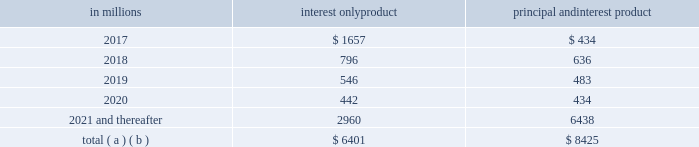Brokered home equity lines of credit ) .
As part of our overall risk analysis and monitoring , we segment the home equity portfolio based upon the loan delinquency , modification status and bankruptcy status , as well as the delinquency , modification status and bankruptcy status of any mortgage loan with the same borrower ( regardless of whether it is a first lien senior to our second lien ) .
In establishing our alll for non-impaired loans , we utilize a delinquency roll-rate methodology for pools of loans .
The roll-rate methodology estimates transition/roll of loan balances from one delinquency state to the next delinquency state and ultimately to charge-off .
The roll through to charge-off is based on our actual loss experience for each type of pool .
Each of our home equity pools contains both first and second liens .
Our experience has been that the ratio of first to second lien loans has been consistent over time and the charge-off amounts for the pools , used to establish our allowance , include losses on both first and second lien loans .
Generally , our variable-rate home equity lines of credit have either a seven or ten year draw period , followed by a 20-year amortization term .
During the draw period , we have home equity lines of credit where borrowers pay either interest only or principal and interest .
We view home equity lines of credit where borrowers are paying principal and interest under the draw period as less risky than those where the borrowers are paying interest only , as these borrowers have a demonstrated ability to make some level of principal and interest payments .
The risk associated with the borrower 2019s ability to satisfy the loan terms upon the draw period ending is considered in establishing our alll .
Based upon outstanding balances at december 31 , 2016 , the table presents the periods when home equity lines of credit draw periods are scheduled to end .
Table 18 : home equity lines of credit 2013 draw period end in millions interest only product principal and interest product .
( a ) includes all home equity lines of credit that mature in 2017 or later , including those with borrowers where we have terminated borrowing privileges .
( b ) includes home equity lines of credit with balloon payments , including those where we have terminated borrowing privileges , of $ 35 million , $ 27 million , $ 20 million , $ 71 million and $ 416 million with draw periods scheduled to end in 2017 , 2018 , 2019 , 2020 and 2021 and thereafter , respectively .
Based upon outstanding balances , and excluding purchased impaired loans , at december 31 , 2016 , for home equity lines of credit for which the borrower can no longer draw ( e.g. , draw period has ended or borrowing privileges have been terminated ) , approximately 3% ( 3 % ) were 30-89 days past due and approximately 6% ( 6 % ) were 90 days or more past due , which are accounted for as nonperforming .
Generally , when a borrower becomes 60 days past due , we terminate borrowing privileges and those privileges are not subsequently reinstated .
At that point , we continue our collection/recovery processes , which may include loan modification resulting in a loan that is classified as a tdr .
Auto loan portfolio the auto loan portfolio totaled $ 12.4 billion as of december 31 , 2016 , or 6% ( 6 % ) of our total loan portfolio .
Of that total , $ 10.8 billion resides in the indirect auto portfolio , $ 1.3 billion in the direct auto portfolio , and $ .3 billion in acquired or securitized portfolios , which has been declining as no pools have been recently acquired .
Indirect auto loan applications are generated from franchised automobile dealers .
This business is strategically aligned with our core retail business .
We have elected not to pursue non-prime auto lending as evidenced by an average new loan origination fico score during 2016 of 760 for indirect auto loans and 775 for direct auto loans .
As of december 31 , 2016 , .4% ( .4 % ) of our auto loan portfolio was nonperforming and .5% ( .5 % ) of the portfolio was accruing past due .
We offer both new and used automobile financing to customers through our various channels .
The portfolio was composed of 57% ( 57 % ) new vehicle loans and 43% ( 43 % ) used vehicle loans at december 31 , 2016 .
The auto loan portfolio 2019s performance is measured monthly , including updated collateral values that are obtained monthly and updated fico scores that are obtained at least quarterly .
For internal reporting and risk management , we analyze the portfolio by product channel and product type , and regularly evaluate default and delinquency experience .
As part of our overall risk analysis and monitoring , we segment the portfolio by loan structure , collateral attributes , and credit metrics which include fico score , loan-to-value and term .
Energy related loan portfolio our portfolio of loans outstanding in the oil and gas industry totaled $ 2.4 billion as of december 31 , 2016 , or 1% ( 1 % ) of our total loan portfolio and 2% ( 2 % ) of our total commercial lending portfolio .
This portfolio comprised approximately $ 1.0 billion in the midstream and downstream sectors , $ .8 billion to oil services companies and $ .6 billion to upstream sectors .
Of the oil services portfolio , approximately $ .2 billion is not asset- based or investment grade .
Nonperforming loans in the oil and gas sector as of december 31 , 2016 totaled $ 184 million , or 8% ( 8 % ) of total nonperforming assets .
Our portfolio of loans outstanding in the coal industry totaled $ .4 billion as of december 31 , 2016 , or less than 1% ( 1 % ) of both our total loan portfolio and our total commercial lending portfolio .
Nonperforming loans in the coal industry as of december 31 , 2016 totaled $ 61 million , or 3% ( 3 % ) of total nonperforming assets .
The pnc financial services group , inc .
2013 form 10-k 57 .
Was the interest only product balance for the 2017 draw period greater than the 2018 draw period?\\n\\n? 
Computations: (1657 > 796)
Answer: yes. Brokered home equity lines of credit ) .
As part of our overall risk analysis and monitoring , we segment the home equity portfolio based upon the loan delinquency , modification status and bankruptcy status , as well as the delinquency , modification status and bankruptcy status of any mortgage loan with the same borrower ( regardless of whether it is a first lien senior to our second lien ) .
In establishing our alll for non-impaired loans , we utilize a delinquency roll-rate methodology for pools of loans .
The roll-rate methodology estimates transition/roll of loan balances from one delinquency state to the next delinquency state and ultimately to charge-off .
The roll through to charge-off is based on our actual loss experience for each type of pool .
Each of our home equity pools contains both first and second liens .
Our experience has been that the ratio of first to second lien loans has been consistent over time and the charge-off amounts for the pools , used to establish our allowance , include losses on both first and second lien loans .
Generally , our variable-rate home equity lines of credit have either a seven or ten year draw period , followed by a 20-year amortization term .
During the draw period , we have home equity lines of credit where borrowers pay either interest only or principal and interest .
We view home equity lines of credit where borrowers are paying principal and interest under the draw period as less risky than those where the borrowers are paying interest only , as these borrowers have a demonstrated ability to make some level of principal and interest payments .
The risk associated with the borrower 2019s ability to satisfy the loan terms upon the draw period ending is considered in establishing our alll .
Based upon outstanding balances at december 31 , 2016 , the table presents the periods when home equity lines of credit draw periods are scheduled to end .
Table 18 : home equity lines of credit 2013 draw period end in millions interest only product principal and interest product .
( a ) includes all home equity lines of credit that mature in 2017 or later , including those with borrowers where we have terminated borrowing privileges .
( b ) includes home equity lines of credit with balloon payments , including those where we have terminated borrowing privileges , of $ 35 million , $ 27 million , $ 20 million , $ 71 million and $ 416 million with draw periods scheduled to end in 2017 , 2018 , 2019 , 2020 and 2021 and thereafter , respectively .
Based upon outstanding balances , and excluding purchased impaired loans , at december 31 , 2016 , for home equity lines of credit for which the borrower can no longer draw ( e.g. , draw period has ended or borrowing privileges have been terminated ) , approximately 3% ( 3 % ) were 30-89 days past due and approximately 6% ( 6 % ) were 90 days or more past due , which are accounted for as nonperforming .
Generally , when a borrower becomes 60 days past due , we terminate borrowing privileges and those privileges are not subsequently reinstated .
At that point , we continue our collection/recovery processes , which may include loan modification resulting in a loan that is classified as a tdr .
Auto loan portfolio the auto loan portfolio totaled $ 12.4 billion as of december 31 , 2016 , or 6% ( 6 % ) of our total loan portfolio .
Of that total , $ 10.8 billion resides in the indirect auto portfolio , $ 1.3 billion in the direct auto portfolio , and $ .3 billion in acquired or securitized portfolios , which has been declining as no pools have been recently acquired .
Indirect auto loan applications are generated from franchised automobile dealers .
This business is strategically aligned with our core retail business .
We have elected not to pursue non-prime auto lending as evidenced by an average new loan origination fico score during 2016 of 760 for indirect auto loans and 775 for direct auto loans .
As of december 31 , 2016 , .4% ( .4 % ) of our auto loan portfolio was nonperforming and .5% ( .5 % ) of the portfolio was accruing past due .
We offer both new and used automobile financing to customers through our various channels .
The portfolio was composed of 57% ( 57 % ) new vehicle loans and 43% ( 43 % ) used vehicle loans at december 31 , 2016 .
The auto loan portfolio 2019s performance is measured monthly , including updated collateral values that are obtained monthly and updated fico scores that are obtained at least quarterly .
For internal reporting and risk management , we analyze the portfolio by product channel and product type , and regularly evaluate default and delinquency experience .
As part of our overall risk analysis and monitoring , we segment the portfolio by loan structure , collateral attributes , and credit metrics which include fico score , loan-to-value and term .
Energy related loan portfolio our portfolio of loans outstanding in the oil and gas industry totaled $ 2.4 billion as of december 31 , 2016 , or 1% ( 1 % ) of our total loan portfolio and 2% ( 2 % ) of our total commercial lending portfolio .
This portfolio comprised approximately $ 1.0 billion in the midstream and downstream sectors , $ .8 billion to oil services companies and $ .6 billion to upstream sectors .
Of the oil services portfolio , approximately $ .2 billion is not asset- based or investment grade .
Nonperforming loans in the oil and gas sector as of december 31 , 2016 totaled $ 184 million , or 8% ( 8 % ) of total nonperforming assets .
Our portfolio of loans outstanding in the coal industry totaled $ .4 billion as of december 31 , 2016 , or less than 1% ( 1 % ) of both our total loan portfolio and our total commercial lending portfolio .
Nonperforming loans in the coal industry as of december 31 , 2016 totaled $ 61 million , or 3% ( 3 % ) of total nonperforming assets .
The pnc financial services group , inc .
2013 form 10-k 57 .
In millions , what was total outstanding for interest only products plus principal and interest products? 
Computations: (6401 + 8425)
Answer: 14826.0. 